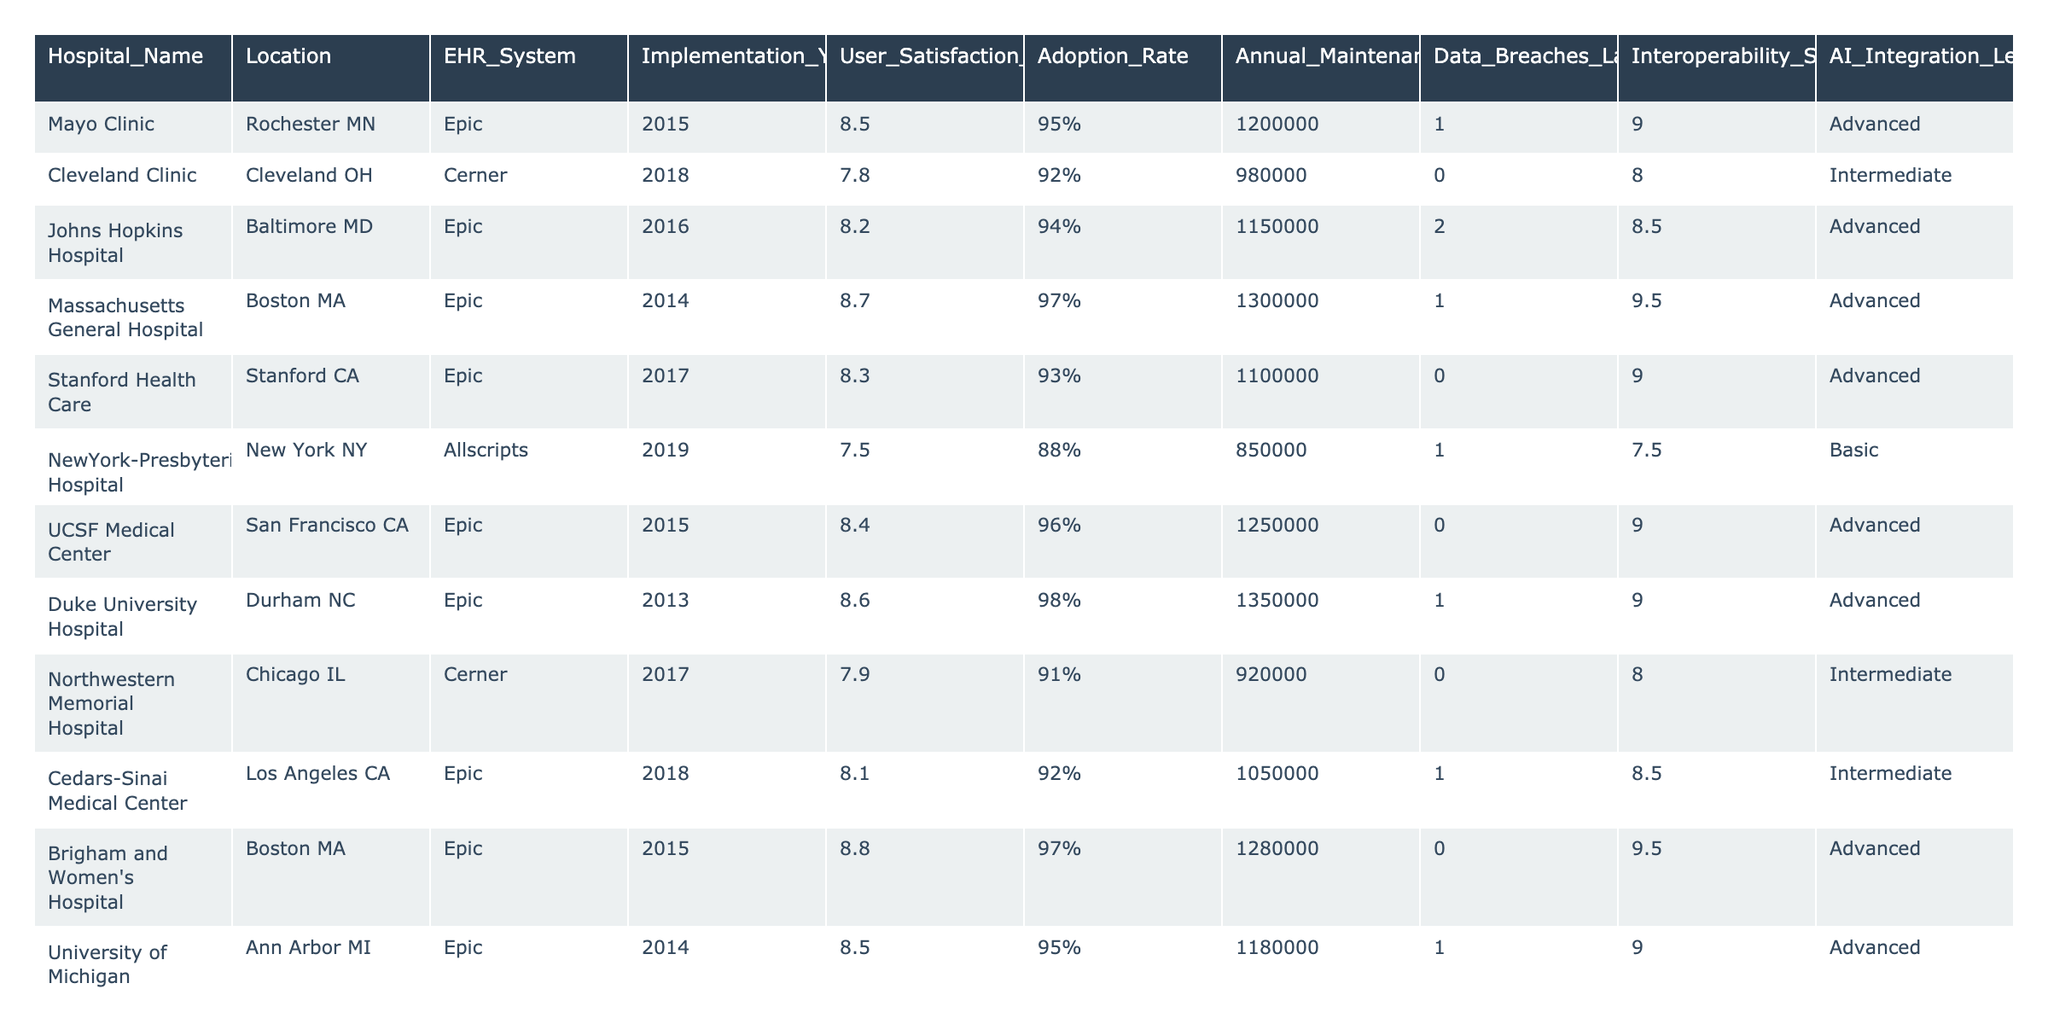What is the User Satisfaction Score of Massachusetts General Hospital? The User Satisfaction Score of Massachusetts General Hospital is listed in the table as 8.7.
Answer: 8.7 Which hospital has the highest Adoption Rate? By checking the Adoption Rate column, Mayo Clinic has the highest rate at 95%.
Answer: Mayo Clinic What is the average Annual Maintenance Cost of the Epic systems? The Annual Maintenance Costs for Epic systems are: 1200000, 1150000, 1300000, 1100000, 1250000, 1350000, 1280000, 1180000, and 1100000. Summing these values gives 1,163,000, and dividing by 9 (the number of Epic systems) results in an average of approximately 1,171,111.
Answer: 1171111 How many hospitals experienced Data Breaches in the last 5 years? Counting the entries under the Data Breaches column that are greater than 0, there are 5 hospitals that experienced breaches.
Answer: 5 Is there a correlation between User Satisfaction Score and Interoperability Score for Epic systems? By observing the User Satisfaction Scores and corresponding Interoperability Scores for Epic systems, we see varying scores that do not present a consistent pattern. Hence, no direct correlation can be established.
Answer: No Which hospital has the lowest AI Integration Level and what is it? The hospital with the lowest AI Integration Level is NewYork-Presbyterian Hospital, which has a Basic level.
Answer: NewYork-Presbyterian Hospital, Basic What is the difference in Annual Maintenance Cost between the highest and lowest for Cerner systems? The Annual Maintenance Cost for Barnes-Jewish Hospital (Cerner) is 900,000, and for Cleveland Clinic (Cerner) it is 980,000. The difference is 980,000 - 900,000 = 80,000.
Answer: 80000 How does the User Satisfaction Score of Johns Hopkins Hospital compare to that of Cleveland Clinic? Johns Hopkins Hospital has a User Satisfaction Score of 8.2, which is lower than Cleveland Clinic's score of 7.8, indicating Johns Hopkins has a higher satisfaction level.
Answer: Higher Which EHR System has the highest average User Satisfaction Score among the listed hospitals? The User Satisfaction Scores for Epic systems are: 8.5, 8.2, 8.7, 8.3, 8.4, 8.6, 8.8, 8.5, and 8.0, summing to 78.5 and dividing by 9 gives an average of approximately 8.72. The Cerner systems average is 7.8, indicating Epic has higher average satisfaction.
Answer: Epic What percentage of hospitals using Epic have a User Satisfaction Score over 8.5? There are 5 hospitals using Epic with scores: 8.5, 8.2, 8.7, 8.3, 8.4, 8.6, 8.8, and 8.5. Of these, 5 have scores over 8.5. Therefore, 5 out of 9 is about 55.56%, which can be simplified to 56% when rounded.
Answer: 56% 